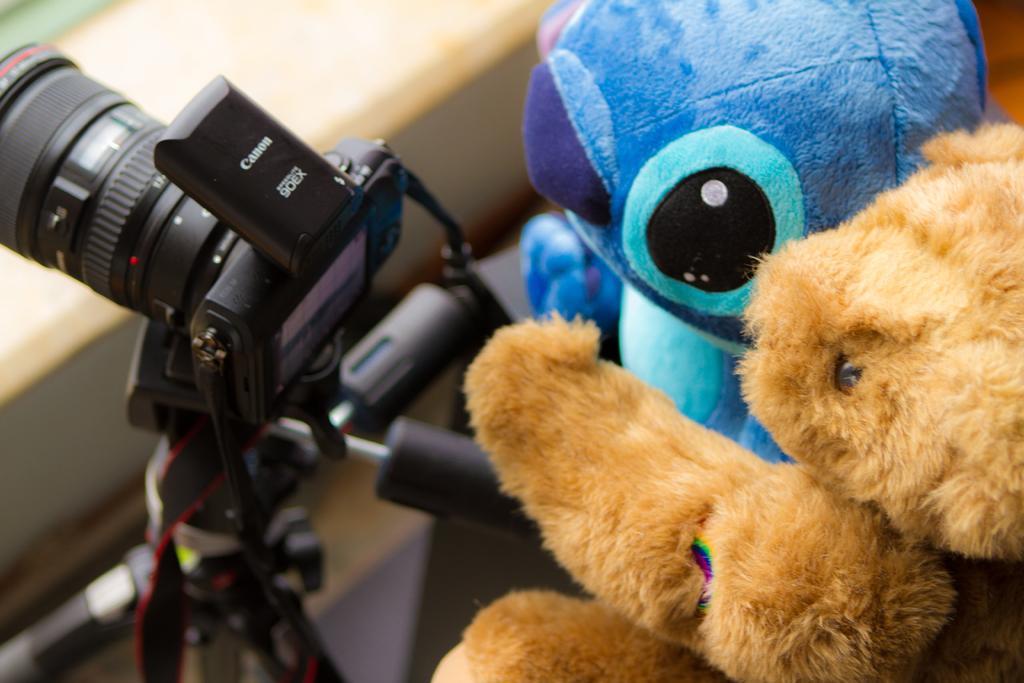How would you summarize this image in a sentence or two? In this image in the front there are dolls and on the left side there is a camera which is black in colour with some text written on it. 